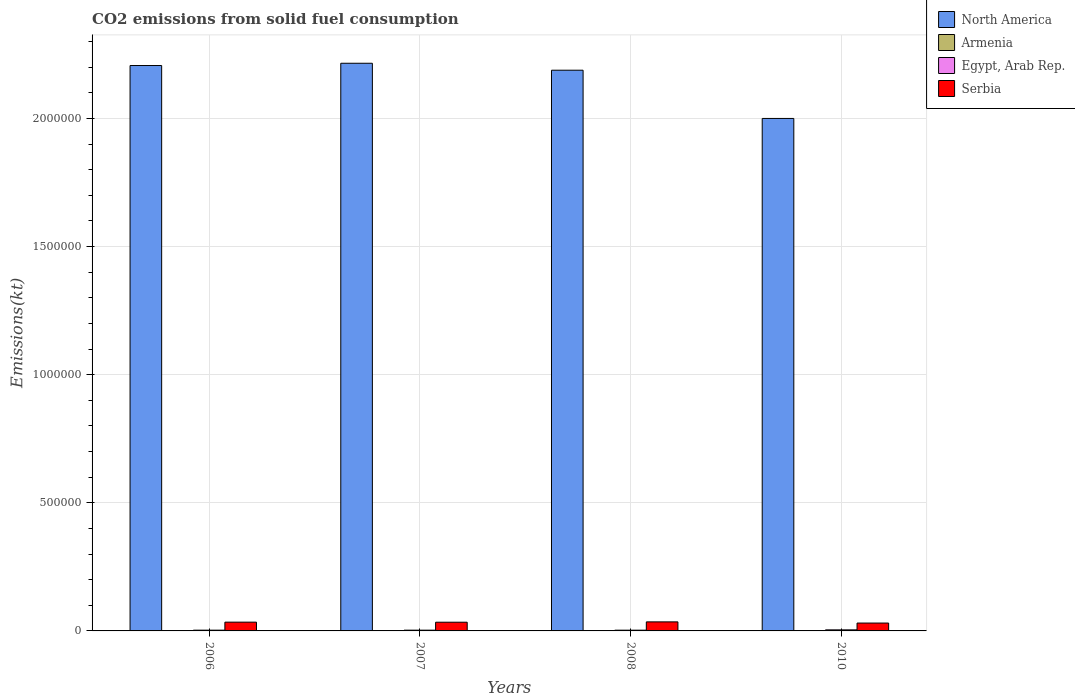How many different coloured bars are there?
Offer a very short reply. 4. How many groups of bars are there?
Offer a very short reply. 4. What is the label of the 1st group of bars from the left?
Provide a succinct answer. 2006. In how many cases, is the number of bars for a given year not equal to the number of legend labels?
Provide a short and direct response. 0. What is the amount of CO2 emitted in Armenia in 2008?
Your answer should be very brief. 18.34. Across all years, what is the maximum amount of CO2 emitted in Serbia?
Offer a terse response. 3.53e+04. Across all years, what is the minimum amount of CO2 emitted in Egypt, Arab Rep.?
Keep it short and to the point. 2885.93. What is the total amount of CO2 emitted in Armenia in the graph?
Make the answer very short. 47.67. What is the difference between the amount of CO2 emitted in Armenia in 2006 and that in 2010?
Your response must be concise. -7.33. What is the difference between the amount of CO2 emitted in Serbia in 2008 and the amount of CO2 emitted in North America in 2010?
Keep it short and to the point. -1.96e+06. What is the average amount of CO2 emitted in Serbia per year?
Offer a terse response. 3.36e+04. In the year 2010, what is the difference between the amount of CO2 emitted in North America and amount of CO2 emitted in Egypt, Arab Rep.?
Make the answer very short. 2.00e+06. In how many years, is the amount of CO2 emitted in Serbia greater than 1000000 kt?
Provide a succinct answer. 0. What is the ratio of the amount of CO2 emitted in North America in 2007 to that in 2010?
Your answer should be compact. 1.11. What is the difference between the highest and the second highest amount of CO2 emitted in Armenia?
Provide a succinct answer. 3.67. What is the difference between the highest and the lowest amount of CO2 emitted in North America?
Keep it short and to the point. 2.15e+05. In how many years, is the amount of CO2 emitted in North America greater than the average amount of CO2 emitted in North America taken over all years?
Keep it short and to the point. 3. What does the 2nd bar from the left in 2006 represents?
Ensure brevity in your answer.  Armenia. How many years are there in the graph?
Ensure brevity in your answer.  4. Does the graph contain grids?
Your answer should be very brief. Yes. How are the legend labels stacked?
Your response must be concise. Vertical. What is the title of the graph?
Offer a very short reply. CO2 emissions from solid fuel consumption. What is the label or title of the Y-axis?
Your response must be concise. Emissions(kt). What is the Emissions(kt) of North America in 2006?
Your answer should be compact. 2.21e+06. What is the Emissions(kt) in Armenia in 2006?
Keep it short and to the point. 3.67. What is the Emissions(kt) in Egypt, Arab Rep. in 2006?
Offer a very short reply. 2959.27. What is the Emissions(kt) in Serbia in 2006?
Your response must be concise. 3.42e+04. What is the Emissions(kt) of North America in 2007?
Offer a terse response. 2.22e+06. What is the Emissions(kt) of Armenia in 2007?
Provide a short and direct response. 14.67. What is the Emissions(kt) in Egypt, Arab Rep. in 2007?
Your answer should be compact. 2951.93. What is the Emissions(kt) of Serbia in 2007?
Offer a terse response. 3.40e+04. What is the Emissions(kt) in North America in 2008?
Provide a short and direct response. 2.19e+06. What is the Emissions(kt) of Armenia in 2008?
Provide a short and direct response. 18.34. What is the Emissions(kt) in Egypt, Arab Rep. in 2008?
Provide a short and direct response. 2885.93. What is the Emissions(kt) of Serbia in 2008?
Give a very brief answer. 3.53e+04. What is the Emissions(kt) in North America in 2010?
Your response must be concise. 2.00e+06. What is the Emissions(kt) in Armenia in 2010?
Give a very brief answer. 11. What is the Emissions(kt) of Egypt, Arab Rep. in 2010?
Ensure brevity in your answer.  4158.38. What is the Emissions(kt) in Serbia in 2010?
Make the answer very short. 3.07e+04. Across all years, what is the maximum Emissions(kt) of North America?
Your answer should be very brief. 2.22e+06. Across all years, what is the maximum Emissions(kt) in Armenia?
Ensure brevity in your answer.  18.34. Across all years, what is the maximum Emissions(kt) of Egypt, Arab Rep.?
Provide a succinct answer. 4158.38. Across all years, what is the maximum Emissions(kt) of Serbia?
Keep it short and to the point. 3.53e+04. Across all years, what is the minimum Emissions(kt) of North America?
Your response must be concise. 2.00e+06. Across all years, what is the minimum Emissions(kt) in Armenia?
Offer a terse response. 3.67. Across all years, what is the minimum Emissions(kt) in Egypt, Arab Rep.?
Offer a very short reply. 2885.93. Across all years, what is the minimum Emissions(kt) of Serbia?
Provide a succinct answer. 3.07e+04. What is the total Emissions(kt) of North America in the graph?
Your answer should be compact. 8.61e+06. What is the total Emissions(kt) of Armenia in the graph?
Your answer should be very brief. 47.67. What is the total Emissions(kt) of Egypt, Arab Rep. in the graph?
Give a very brief answer. 1.30e+04. What is the total Emissions(kt) in Serbia in the graph?
Your response must be concise. 1.34e+05. What is the difference between the Emissions(kt) of North America in 2006 and that in 2007?
Provide a short and direct response. -8863.19. What is the difference between the Emissions(kt) of Armenia in 2006 and that in 2007?
Keep it short and to the point. -11. What is the difference between the Emissions(kt) in Egypt, Arab Rep. in 2006 and that in 2007?
Your answer should be very brief. 7.33. What is the difference between the Emissions(kt) in Serbia in 2006 and that in 2007?
Provide a short and direct response. 238.35. What is the difference between the Emissions(kt) of North America in 2006 and that in 2008?
Provide a short and direct response. 1.83e+04. What is the difference between the Emissions(kt) in Armenia in 2006 and that in 2008?
Make the answer very short. -14.67. What is the difference between the Emissions(kt) in Egypt, Arab Rep. in 2006 and that in 2008?
Make the answer very short. 73.34. What is the difference between the Emissions(kt) in Serbia in 2006 and that in 2008?
Provide a succinct answer. -1056.1. What is the difference between the Emissions(kt) in North America in 2006 and that in 2010?
Keep it short and to the point. 2.06e+05. What is the difference between the Emissions(kt) in Armenia in 2006 and that in 2010?
Give a very brief answer. -7.33. What is the difference between the Emissions(kt) of Egypt, Arab Rep. in 2006 and that in 2010?
Make the answer very short. -1199.11. What is the difference between the Emissions(kt) of Serbia in 2006 and that in 2010?
Your response must be concise. 3564.32. What is the difference between the Emissions(kt) in North America in 2007 and that in 2008?
Give a very brief answer. 2.71e+04. What is the difference between the Emissions(kt) in Armenia in 2007 and that in 2008?
Offer a very short reply. -3.67. What is the difference between the Emissions(kt) in Egypt, Arab Rep. in 2007 and that in 2008?
Your answer should be very brief. 66.01. What is the difference between the Emissions(kt) of Serbia in 2007 and that in 2008?
Your response must be concise. -1294.45. What is the difference between the Emissions(kt) in North America in 2007 and that in 2010?
Keep it short and to the point. 2.15e+05. What is the difference between the Emissions(kt) in Armenia in 2007 and that in 2010?
Make the answer very short. 3.67. What is the difference between the Emissions(kt) in Egypt, Arab Rep. in 2007 and that in 2010?
Provide a succinct answer. -1206.44. What is the difference between the Emissions(kt) of Serbia in 2007 and that in 2010?
Give a very brief answer. 3325.97. What is the difference between the Emissions(kt) of North America in 2008 and that in 2010?
Ensure brevity in your answer.  1.88e+05. What is the difference between the Emissions(kt) in Armenia in 2008 and that in 2010?
Give a very brief answer. 7.33. What is the difference between the Emissions(kt) of Egypt, Arab Rep. in 2008 and that in 2010?
Provide a succinct answer. -1272.45. What is the difference between the Emissions(kt) of Serbia in 2008 and that in 2010?
Make the answer very short. 4620.42. What is the difference between the Emissions(kt) in North America in 2006 and the Emissions(kt) in Armenia in 2007?
Provide a short and direct response. 2.21e+06. What is the difference between the Emissions(kt) in North America in 2006 and the Emissions(kt) in Egypt, Arab Rep. in 2007?
Provide a succinct answer. 2.20e+06. What is the difference between the Emissions(kt) of North America in 2006 and the Emissions(kt) of Serbia in 2007?
Your answer should be very brief. 2.17e+06. What is the difference between the Emissions(kt) of Armenia in 2006 and the Emissions(kt) of Egypt, Arab Rep. in 2007?
Give a very brief answer. -2948.27. What is the difference between the Emissions(kt) of Armenia in 2006 and the Emissions(kt) of Serbia in 2007?
Give a very brief answer. -3.40e+04. What is the difference between the Emissions(kt) in Egypt, Arab Rep. in 2006 and the Emissions(kt) in Serbia in 2007?
Offer a terse response. -3.10e+04. What is the difference between the Emissions(kt) in North America in 2006 and the Emissions(kt) in Armenia in 2008?
Ensure brevity in your answer.  2.21e+06. What is the difference between the Emissions(kt) in North America in 2006 and the Emissions(kt) in Egypt, Arab Rep. in 2008?
Your answer should be very brief. 2.20e+06. What is the difference between the Emissions(kt) in North America in 2006 and the Emissions(kt) in Serbia in 2008?
Offer a very short reply. 2.17e+06. What is the difference between the Emissions(kt) in Armenia in 2006 and the Emissions(kt) in Egypt, Arab Rep. in 2008?
Your response must be concise. -2882.26. What is the difference between the Emissions(kt) in Armenia in 2006 and the Emissions(kt) in Serbia in 2008?
Make the answer very short. -3.53e+04. What is the difference between the Emissions(kt) of Egypt, Arab Rep. in 2006 and the Emissions(kt) of Serbia in 2008?
Provide a short and direct response. -3.23e+04. What is the difference between the Emissions(kt) of North America in 2006 and the Emissions(kt) of Armenia in 2010?
Provide a succinct answer. 2.21e+06. What is the difference between the Emissions(kt) of North America in 2006 and the Emissions(kt) of Egypt, Arab Rep. in 2010?
Ensure brevity in your answer.  2.20e+06. What is the difference between the Emissions(kt) in North America in 2006 and the Emissions(kt) in Serbia in 2010?
Your answer should be very brief. 2.18e+06. What is the difference between the Emissions(kt) of Armenia in 2006 and the Emissions(kt) of Egypt, Arab Rep. in 2010?
Your answer should be compact. -4154.71. What is the difference between the Emissions(kt) in Armenia in 2006 and the Emissions(kt) in Serbia in 2010?
Your answer should be very brief. -3.07e+04. What is the difference between the Emissions(kt) in Egypt, Arab Rep. in 2006 and the Emissions(kt) in Serbia in 2010?
Your response must be concise. -2.77e+04. What is the difference between the Emissions(kt) in North America in 2007 and the Emissions(kt) in Armenia in 2008?
Keep it short and to the point. 2.22e+06. What is the difference between the Emissions(kt) in North America in 2007 and the Emissions(kt) in Egypt, Arab Rep. in 2008?
Offer a terse response. 2.21e+06. What is the difference between the Emissions(kt) in North America in 2007 and the Emissions(kt) in Serbia in 2008?
Provide a succinct answer. 2.18e+06. What is the difference between the Emissions(kt) of Armenia in 2007 and the Emissions(kt) of Egypt, Arab Rep. in 2008?
Provide a succinct answer. -2871.26. What is the difference between the Emissions(kt) of Armenia in 2007 and the Emissions(kt) of Serbia in 2008?
Offer a very short reply. -3.53e+04. What is the difference between the Emissions(kt) of Egypt, Arab Rep. in 2007 and the Emissions(kt) of Serbia in 2008?
Your response must be concise. -3.23e+04. What is the difference between the Emissions(kt) in North America in 2007 and the Emissions(kt) in Armenia in 2010?
Offer a terse response. 2.22e+06. What is the difference between the Emissions(kt) in North America in 2007 and the Emissions(kt) in Egypt, Arab Rep. in 2010?
Give a very brief answer. 2.21e+06. What is the difference between the Emissions(kt) of North America in 2007 and the Emissions(kt) of Serbia in 2010?
Keep it short and to the point. 2.18e+06. What is the difference between the Emissions(kt) of Armenia in 2007 and the Emissions(kt) of Egypt, Arab Rep. in 2010?
Keep it short and to the point. -4143.71. What is the difference between the Emissions(kt) of Armenia in 2007 and the Emissions(kt) of Serbia in 2010?
Provide a succinct answer. -3.07e+04. What is the difference between the Emissions(kt) of Egypt, Arab Rep. in 2007 and the Emissions(kt) of Serbia in 2010?
Make the answer very short. -2.77e+04. What is the difference between the Emissions(kt) in North America in 2008 and the Emissions(kt) in Armenia in 2010?
Your answer should be compact. 2.19e+06. What is the difference between the Emissions(kt) in North America in 2008 and the Emissions(kt) in Egypt, Arab Rep. in 2010?
Ensure brevity in your answer.  2.18e+06. What is the difference between the Emissions(kt) in North America in 2008 and the Emissions(kt) in Serbia in 2010?
Your answer should be very brief. 2.16e+06. What is the difference between the Emissions(kt) in Armenia in 2008 and the Emissions(kt) in Egypt, Arab Rep. in 2010?
Make the answer very short. -4140.04. What is the difference between the Emissions(kt) of Armenia in 2008 and the Emissions(kt) of Serbia in 2010?
Ensure brevity in your answer.  -3.07e+04. What is the difference between the Emissions(kt) of Egypt, Arab Rep. in 2008 and the Emissions(kt) of Serbia in 2010?
Keep it short and to the point. -2.78e+04. What is the average Emissions(kt) of North America per year?
Ensure brevity in your answer.  2.15e+06. What is the average Emissions(kt) in Armenia per year?
Your response must be concise. 11.92. What is the average Emissions(kt) of Egypt, Arab Rep. per year?
Your answer should be very brief. 3238.88. What is the average Emissions(kt) in Serbia per year?
Provide a short and direct response. 3.36e+04. In the year 2006, what is the difference between the Emissions(kt) of North America and Emissions(kt) of Armenia?
Provide a succinct answer. 2.21e+06. In the year 2006, what is the difference between the Emissions(kt) in North America and Emissions(kt) in Egypt, Arab Rep.?
Ensure brevity in your answer.  2.20e+06. In the year 2006, what is the difference between the Emissions(kt) of North America and Emissions(kt) of Serbia?
Give a very brief answer. 2.17e+06. In the year 2006, what is the difference between the Emissions(kt) of Armenia and Emissions(kt) of Egypt, Arab Rep.?
Provide a short and direct response. -2955.6. In the year 2006, what is the difference between the Emissions(kt) in Armenia and Emissions(kt) in Serbia?
Provide a short and direct response. -3.42e+04. In the year 2006, what is the difference between the Emissions(kt) of Egypt, Arab Rep. and Emissions(kt) of Serbia?
Ensure brevity in your answer.  -3.13e+04. In the year 2007, what is the difference between the Emissions(kt) of North America and Emissions(kt) of Armenia?
Your response must be concise. 2.22e+06. In the year 2007, what is the difference between the Emissions(kt) of North America and Emissions(kt) of Egypt, Arab Rep.?
Offer a very short reply. 2.21e+06. In the year 2007, what is the difference between the Emissions(kt) of North America and Emissions(kt) of Serbia?
Your answer should be very brief. 2.18e+06. In the year 2007, what is the difference between the Emissions(kt) of Armenia and Emissions(kt) of Egypt, Arab Rep.?
Your response must be concise. -2937.27. In the year 2007, what is the difference between the Emissions(kt) in Armenia and Emissions(kt) in Serbia?
Your answer should be very brief. -3.40e+04. In the year 2007, what is the difference between the Emissions(kt) in Egypt, Arab Rep. and Emissions(kt) in Serbia?
Offer a terse response. -3.11e+04. In the year 2008, what is the difference between the Emissions(kt) of North America and Emissions(kt) of Armenia?
Give a very brief answer. 2.19e+06. In the year 2008, what is the difference between the Emissions(kt) in North America and Emissions(kt) in Egypt, Arab Rep.?
Your answer should be compact. 2.19e+06. In the year 2008, what is the difference between the Emissions(kt) in North America and Emissions(kt) in Serbia?
Your answer should be compact. 2.15e+06. In the year 2008, what is the difference between the Emissions(kt) of Armenia and Emissions(kt) of Egypt, Arab Rep.?
Your answer should be very brief. -2867.59. In the year 2008, what is the difference between the Emissions(kt) in Armenia and Emissions(kt) in Serbia?
Provide a short and direct response. -3.53e+04. In the year 2008, what is the difference between the Emissions(kt) in Egypt, Arab Rep. and Emissions(kt) in Serbia?
Provide a short and direct response. -3.24e+04. In the year 2010, what is the difference between the Emissions(kt) of North America and Emissions(kt) of Armenia?
Your response must be concise. 2.00e+06. In the year 2010, what is the difference between the Emissions(kt) in North America and Emissions(kt) in Egypt, Arab Rep.?
Offer a terse response. 2.00e+06. In the year 2010, what is the difference between the Emissions(kt) in North America and Emissions(kt) in Serbia?
Your response must be concise. 1.97e+06. In the year 2010, what is the difference between the Emissions(kt) of Armenia and Emissions(kt) of Egypt, Arab Rep.?
Make the answer very short. -4147.38. In the year 2010, what is the difference between the Emissions(kt) of Armenia and Emissions(kt) of Serbia?
Keep it short and to the point. -3.07e+04. In the year 2010, what is the difference between the Emissions(kt) of Egypt, Arab Rep. and Emissions(kt) of Serbia?
Your answer should be very brief. -2.65e+04. What is the ratio of the Emissions(kt) of North America in 2006 to that in 2008?
Provide a short and direct response. 1.01. What is the ratio of the Emissions(kt) in Egypt, Arab Rep. in 2006 to that in 2008?
Make the answer very short. 1.03. What is the ratio of the Emissions(kt) in Serbia in 2006 to that in 2008?
Provide a short and direct response. 0.97. What is the ratio of the Emissions(kt) in North America in 2006 to that in 2010?
Provide a short and direct response. 1.1. What is the ratio of the Emissions(kt) of Armenia in 2006 to that in 2010?
Your response must be concise. 0.33. What is the ratio of the Emissions(kt) of Egypt, Arab Rep. in 2006 to that in 2010?
Make the answer very short. 0.71. What is the ratio of the Emissions(kt) of Serbia in 2006 to that in 2010?
Provide a succinct answer. 1.12. What is the ratio of the Emissions(kt) of North America in 2007 to that in 2008?
Make the answer very short. 1.01. What is the ratio of the Emissions(kt) of Egypt, Arab Rep. in 2007 to that in 2008?
Provide a short and direct response. 1.02. What is the ratio of the Emissions(kt) of Serbia in 2007 to that in 2008?
Make the answer very short. 0.96. What is the ratio of the Emissions(kt) in North America in 2007 to that in 2010?
Your answer should be very brief. 1.11. What is the ratio of the Emissions(kt) of Armenia in 2007 to that in 2010?
Offer a terse response. 1.33. What is the ratio of the Emissions(kt) of Egypt, Arab Rep. in 2007 to that in 2010?
Make the answer very short. 0.71. What is the ratio of the Emissions(kt) of Serbia in 2007 to that in 2010?
Your answer should be very brief. 1.11. What is the ratio of the Emissions(kt) in North America in 2008 to that in 2010?
Make the answer very short. 1.09. What is the ratio of the Emissions(kt) of Armenia in 2008 to that in 2010?
Your response must be concise. 1.67. What is the ratio of the Emissions(kt) of Egypt, Arab Rep. in 2008 to that in 2010?
Provide a short and direct response. 0.69. What is the ratio of the Emissions(kt) in Serbia in 2008 to that in 2010?
Your answer should be compact. 1.15. What is the difference between the highest and the second highest Emissions(kt) of North America?
Ensure brevity in your answer.  8863.19. What is the difference between the highest and the second highest Emissions(kt) of Armenia?
Offer a very short reply. 3.67. What is the difference between the highest and the second highest Emissions(kt) in Egypt, Arab Rep.?
Make the answer very short. 1199.11. What is the difference between the highest and the second highest Emissions(kt) in Serbia?
Ensure brevity in your answer.  1056.1. What is the difference between the highest and the lowest Emissions(kt) of North America?
Give a very brief answer. 2.15e+05. What is the difference between the highest and the lowest Emissions(kt) in Armenia?
Make the answer very short. 14.67. What is the difference between the highest and the lowest Emissions(kt) in Egypt, Arab Rep.?
Offer a very short reply. 1272.45. What is the difference between the highest and the lowest Emissions(kt) of Serbia?
Give a very brief answer. 4620.42. 